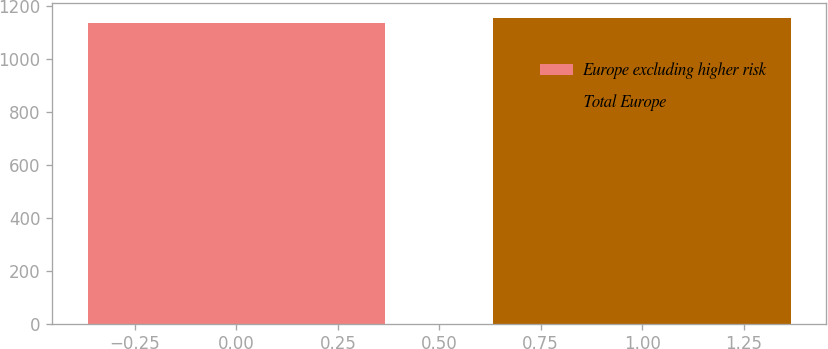Convert chart to OTSL. <chart><loc_0><loc_0><loc_500><loc_500><bar_chart><fcel>Europe excluding higher risk<fcel>Total Europe<nl><fcel>1135<fcel>1154<nl></chart> 